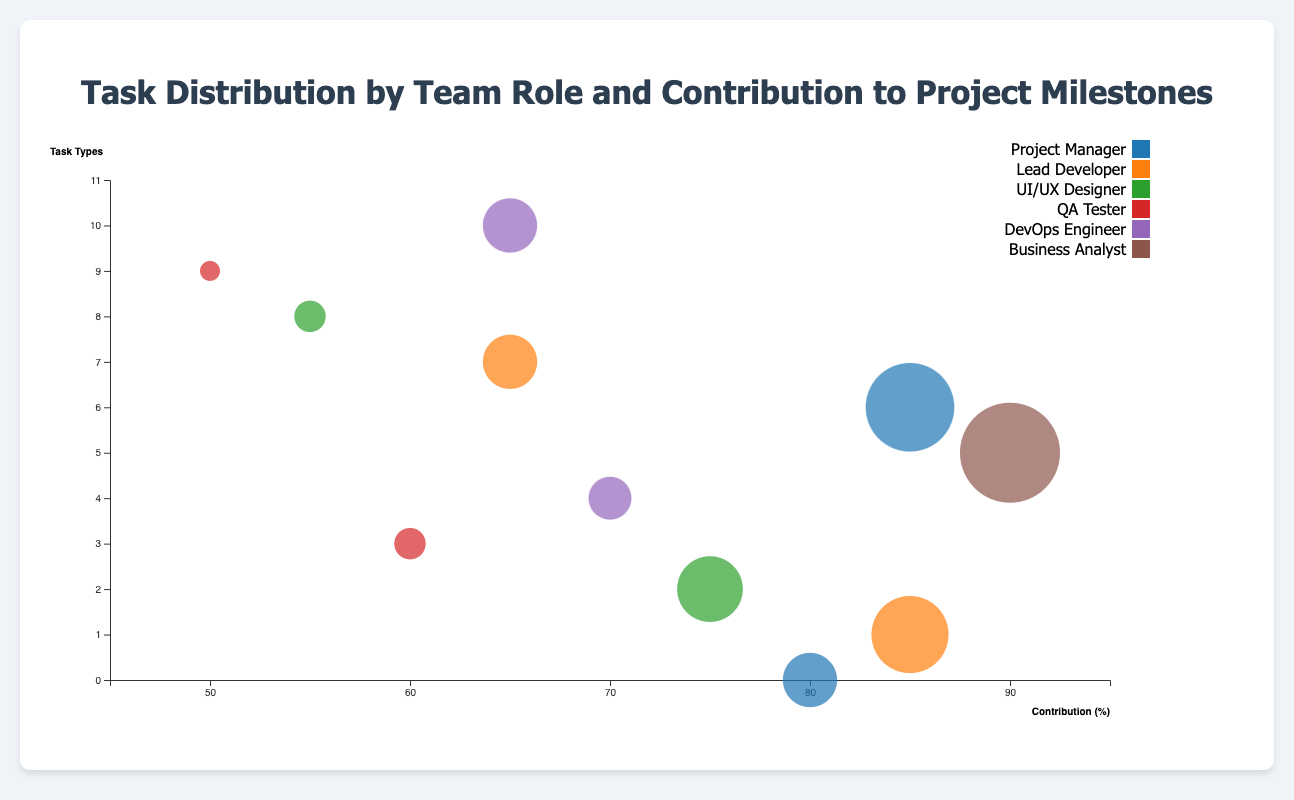What is the title of the figure? Looking at the top of the figure, the title "Task Distribution by Team Role and Contribution to Project Milestones" is clearly displayed.
Answer: Task Distribution by Team Role and Contribution to Project Milestones Which role has the highest contribution? By examining the horizontal axis (Contribution) and finding the furthest right bubble, the role with the highest contribution is the Business Analyst for Requirement Analysis with a contribution of 90%.
Answer: Business Analyst Between QA Tester and DevOps Engineer, which role has the higher average contribution? Calculating the average contributions for QA Tester (60% and 50%) gives (60 + 50) / 2 = 55%, and for DevOps Engineer (70% and 65%) gives (70 + 65) / 2 = 67.5%.
Answer: DevOps Engineer Which milestone is associated with the role that has the largest bubble size? The size of the largest bubble corresponds to the Business Analyst's task of Requirement Analysis, contributing to the milestone "Requirements Sign-Off".
Answer: Requirements Sign-Off Which task related to Lead Developer has the highest contribution? The task "Feature Development" has a contribution of 85%, which is higher than "Code Review" at 65%.
Answer: Feature Development What is the total number of unique roles depicted in the chart? Counting the distinct roles in the data set (Project Manager, Lead Developer, UI/UX Designer, QA Tester, DevOps Engineer, Business Analyst) results in 6 roles.
Answer: 6 How much larger is the contribution of Planning & Strategy compared to Usability Testing? Contribution of Planning & Strategy is 80%, and Usability Testing is 55%. The difference is 80 - 55 = 25%.
Answer: 25% What is the average size of the tasks related to Project Manager? The sizes are 60 and 75. The average size is (60 + 75) / 2 = 67.5.
Answer: 67.5 Which milestone has a contribution represented by the smallest bubble? The smallest bubble has a size of 45, which corresponds to the milestone "Performance Benchmark" associated with Load Testing by QA Tester.
Answer: Performance Benchmark Which tasks are completed by the DevOps Engineer, and what are their contributions? The tasks are "Deployment Automation" with a contribution of 70% and "Monitoring Setup" with a contribution of 65%.
Answer: Deployment Automation 70%, Monitoring Setup 65% 